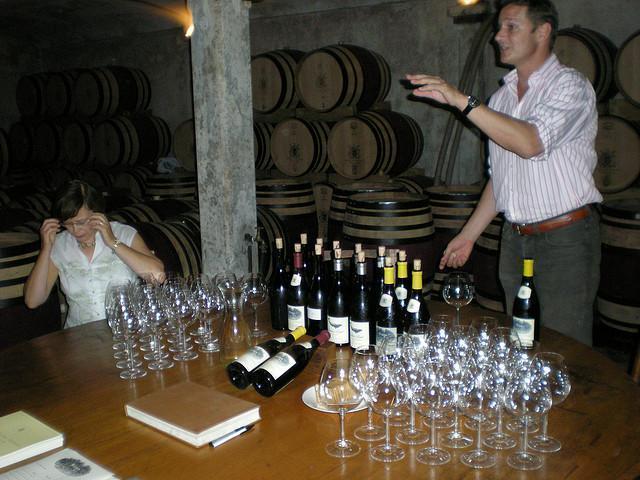What kind of wood is used to make the barrels in the background?
Make your selection from the four choices given to correctly answer the question.
Options: Mahogany, oak, birch, pine. Oak. 